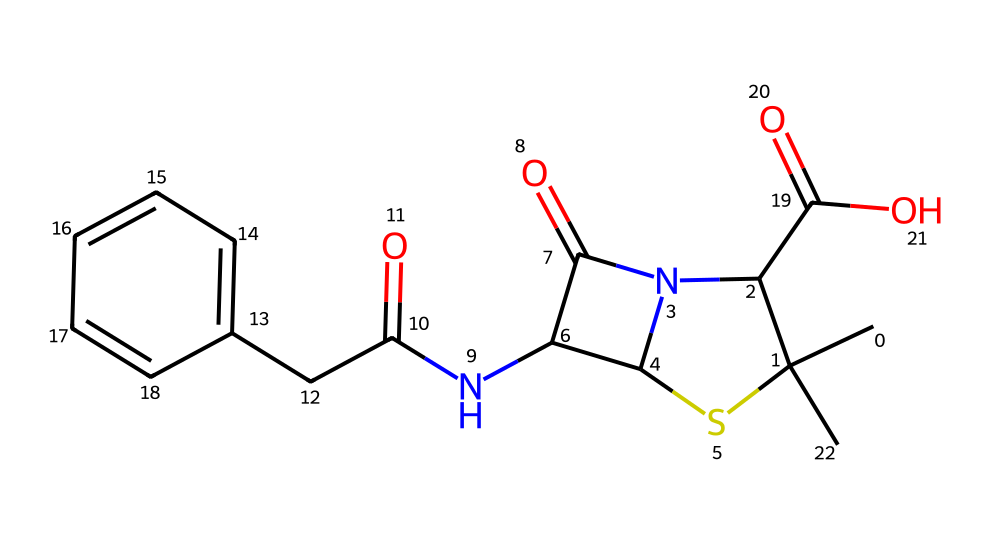What is the total number of nitrogen atoms in this molecule? By analyzing the SMILES representation, we can identify the nitrogen atoms represented by "N." Moving through the structure, there are two occurrences of "N," indicating a total of two nitrogen atoms.
Answer: two How many rings are present in this chemical structure? A careful examination of the SMILES shows that it includes "C1" and "C2," indicating the formation of cycles, which typically represent rings. There are two distinct cycles based on the notation in the SMILES: one from "C(S1)" and another involving "N2" connecting to "C(C2=O)." Therefore, there are 2 rings present.
Answer: two What is the functional group associated with the “C=O” in the structure? The "C=O" in organic chemistry denotes a carbonyl group, which is characteristic of ketones and aldehydes. In the context of antibiotics like penicillin, this falls under the classification of carboxylic acids, as indicated by its presence when assessing the entire structure.
Answer: carboxylic acid Identify the type of molecule represented by this SMILES. This SMILES represents a type of β-lactam antibiotic, a subclass of antimicrobials that include penicillin. This classification stems from the presence of a β-lactam ring, which is critical for its antibacterial activity.
Answer: β-lactam antibiotic What is the maximum number of hydrogen atoms that can be attached to this molecule based on its structure? To determine the maximum number of hydrogen atoms attached, we need to consider each carbon's saturation and account for the presence of nitrogen and oxygen which reduce the number of available hydrogen. After thorough analysis, the saturated form would allow for a maximum of 14 hydrogen atoms, considering typical valency rules for carbon and the structure presented.
Answer: fourteen Is there any element in the structure that typically contributes to antimicrobial activity? Yes, the presence of nitrogen and the β-lactam ring structure are crucial to the mechanism by which penicillin exerts its antimicrobial action. The nitrogen atom is involved in the active site of the enzyme that penicillin targets, which provides it its antibacterial properties.
Answer: nitrogen 